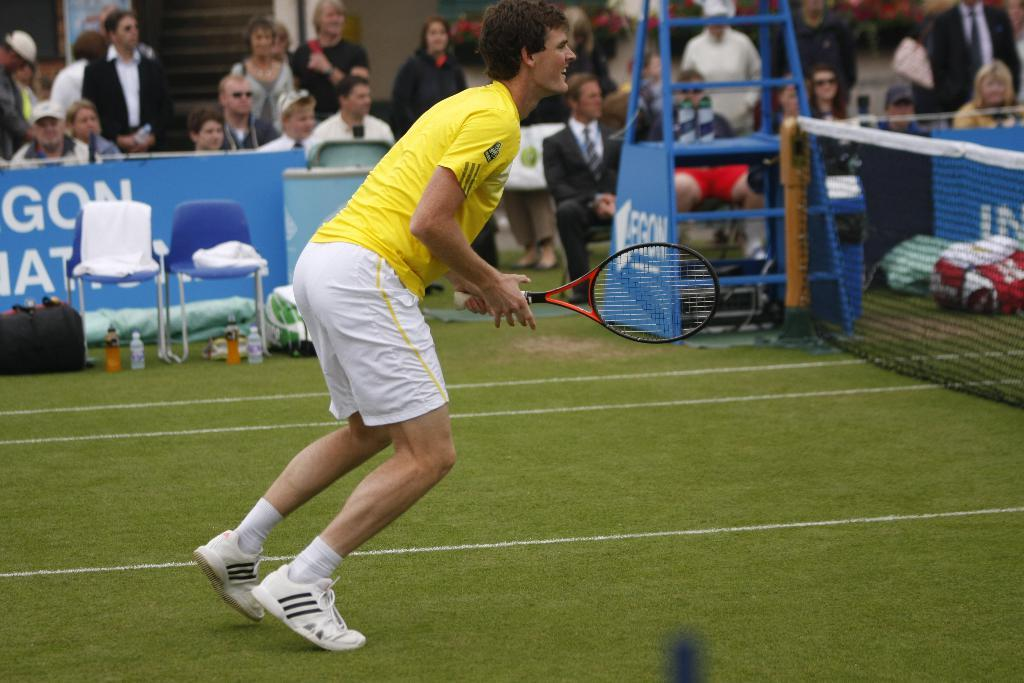What is the man in the image holding? The man is holding a tennis racket. What can be seen in the image besides the man and his tennis racket? There is a net, a chair, a cloth, a bottle, a bag, and people in the background of the image. What additional object is present in the image? There is a ladder in the image. What type of powder is being used to clean the throne in the image? There is no throne present in the image, and therefore no powder or cleaning activity can be observed. 